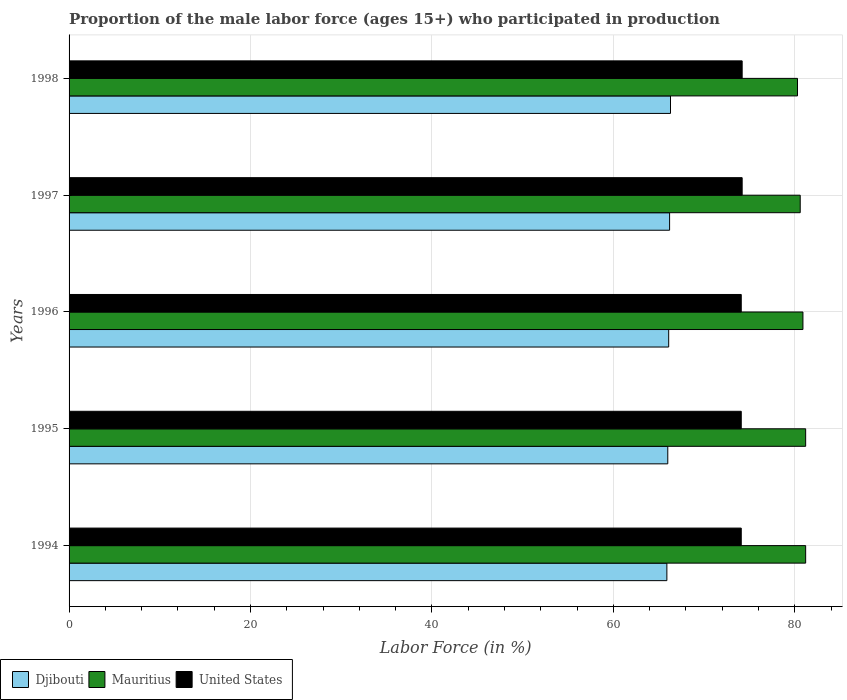How many groups of bars are there?
Ensure brevity in your answer.  5. Are the number of bars per tick equal to the number of legend labels?
Give a very brief answer. Yes. Are the number of bars on each tick of the Y-axis equal?
Your answer should be compact. Yes. How many bars are there on the 3rd tick from the top?
Provide a short and direct response. 3. In how many cases, is the number of bars for a given year not equal to the number of legend labels?
Your answer should be compact. 0. What is the proportion of the male labor force who participated in production in Djibouti in 1996?
Your answer should be compact. 66.1. Across all years, what is the maximum proportion of the male labor force who participated in production in Mauritius?
Ensure brevity in your answer.  81.2. Across all years, what is the minimum proportion of the male labor force who participated in production in United States?
Make the answer very short. 74.1. In which year was the proportion of the male labor force who participated in production in Mauritius minimum?
Provide a succinct answer. 1998. What is the total proportion of the male labor force who participated in production in Djibouti in the graph?
Your response must be concise. 330.5. What is the difference between the proportion of the male labor force who participated in production in United States in 1996 and that in 1998?
Your answer should be compact. -0.1. What is the average proportion of the male labor force who participated in production in Djibouti per year?
Provide a short and direct response. 66.1. In the year 1998, what is the difference between the proportion of the male labor force who participated in production in Mauritius and proportion of the male labor force who participated in production in Djibouti?
Your answer should be compact. 14. In how many years, is the proportion of the male labor force who participated in production in Djibouti greater than 44 %?
Provide a short and direct response. 5. What is the ratio of the proportion of the male labor force who participated in production in United States in 1996 to that in 1997?
Offer a terse response. 1. What is the difference between the highest and the lowest proportion of the male labor force who participated in production in United States?
Make the answer very short. 0.1. In how many years, is the proportion of the male labor force who participated in production in Mauritius greater than the average proportion of the male labor force who participated in production in Mauritius taken over all years?
Offer a terse response. 3. What does the 3rd bar from the top in 1995 represents?
Provide a succinct answer. Djibouti. What does the 2nd bar from the bottom in 1996 represents?
Provide a succinct answer. Mauritius. How many bars are there?
Make the answer very short. 15. How many years are there in the graph?
Make the answer very short. 5. Does the graph contain any zero values?
Your answer should be very brief. No. Does the graph contain grids?
Keep it short and to the point. Yes. Where does the legend appear in the graph?
Your answer should be very brief. Bottom left. How many legend labels are there?
Provide a succinct answer. 3. What is the title of the graph?
Make the answer very short. Proportion of the male labor force (ages 15+) who participated in production. What is the label or title of the X-axis?
Your response must be concise. Labor Force (in %). What is the Labor Force (in %) in Djibouti in 1994?
Keep it short and to the point. 65.9. What is the Labor Force (in %) of Mauritius in 1994?
Your answer should be compact. 81.2. What is the Labor Force (in %) of United States in 1994?
Your response must be concise. 74.1. What is the Labor Force (in %) of Mauritius in 1995?
Offer a terse response. 81.2. What is the Labor Force (in %) of United States in 1995?
Your response must be concise. 74.1. What is the Labor Force (in %) of Djibouti in 1996?
Provide a succinct answer. 66.1. What is the Labor Force (in %) in Mauritius in 1996?
Give a very brief answer. 80.9. What is the Labor Force (in %) in United States in 1996?
Your response must be concise. 74.1. What is the Labor Force (in %) in Djibouti in 1997?
Give a very brief answer. 66.2. What is the Labor Force (in %) of Mauritius in 1997?
Your answer should be very brief. 80.6. What is the Labor Force (in %) of United States in 1997?
Your answer should be very brief. 74.2. What is the Labor Force (in %) in Djibouti in 1998?
Provide a short and direct response. 66.3. What is the Labor Force (in %) of Mauritius in 1998?
Offer a very short reply. 80.3. What is the Labor Force (in %) of United States in 1998?
Your answer should be compact. 74.2. Across all years, what is the maximum Labor Force (in %) in Djibouti?
Keep it short and to the point. 66.3. Across all years, what is the maximum Labor Force (in %) of Mauritius?
Ensure brevity in your answer.  81.2. Across all years, what is the maximum Labor Force (in %) of United States?
Offer a very short reply. 74.2. Across all years, what is the minimum Labor Force (in %) of Djibouti?
Your answer should be very brief. 65.9. Across all years, what is the minimum Labor Force (in %) of Mauritius?
Provide a short and direct response. 80.3. Across all years, what is the minimum Labor Force (in %) of United States?
Your answer should be very brief. 74.1. What is the total Labor Force (in %) in Djibouti in the graph?
Keep it short and to the point. 330.5. What is the total Labor Force (in %) in Mauritius in the graph?
Provide a short and direct response. 404.2. What is the total Labor Force (in %) of United States in the graph?
Offer a terse response. 370.7. What is the difference between the Labor Force (in %) of Mauritius in 1994 and that in 1995?
Provide a short and direct response. 0. What is the difference between the Labor Force (in %) in Djibouti in 1994 and that in 1996?
Ensure brevity in your answer.  -0.2. What is the difference between the Labor Force (in %) in United States in 1994 and that in 1996?
Keep it short and to the point. 0. What is the difference between the Labor Force (in %) of Djibouti in 1994 and that in 1997?
Your response must be concise. -0.3. What is the difference between the Labor Force (in %) in United States in 1994 and that in 1997?
Make the answer very short. -0.1. What is the difference between the Labor Force (in %) in Mauritius in 1994 and that in 1998?
Your answer should be compact. 0.9. What is the difference between the Labor Force (in %) of Djibouti in 1995 and that in 1996?
Ensure brevity in your answer.  -0.1. What is the difference between the Labor Force (in %) of United States in 1995 and that in 1996?
Ensure brevity in your answer.  0. What is the difference between the Labor Force (in %) of Djibouti in 1995 and that in 1997?
Keep it short and to the point. -0.2. What is the difference between the Labor Force (in %) in United States in 1995 and that in 1998?
Your response must be concise. -0.1. What is the difference between the Labor Force (in %) of United States in 1996 and that in 1997?
Give a very brief answer. -0.1. What is the difference between the Labor Force (in %) in Djibouti in 1997 and that in 1998?
Your answer should be compact. -0.1. What is the difference between the Labor Force (in %) in Mauritius in 1997 and that in 1998?
Ensure brevity in your answer.  0.3. What is the difference between the Labor Force (in %) in Djibouti in 1994 and the Labor Force (in %) in Mauritius in 1995?
Keep it short and to the point. -15.3. What is the difference between the Labor Force (in %) of Djibouti in 1994 and the Labor Force (in %) of United States in 1995?
Your answer should be very brief. -8.2. What is the difference between the Labor Force (in %) of Djibouti in 1994 and the Labor Force (in %) of Mauritius in 1996?
Your answer should be compact. -15. What is the difference between the Labor Force (in %) in Djibouti in 1994 and the Labor Force (in %) in United States in 1996?
Ensure brevity in your answer.  -8.2. What is the difference between the Labor Force (in %) in Mauritius in 1994 and the Labor Force (in %) in United States in 1996?
Provide a short and direct response. 7.1. What is the difference between the Labor Force (in %) of Djibouti in 1994 and the Labor Force (in %) of Mauritius in 1997?
Your answer should be very brief. -14.7. What is the difference between the Labor Force (in %) of Mauritius in 1994 and the Labor Force (in %) of United States in 1997?
Keep it short and to the point. 7. What is the difference between the Labor Force (in %) of Djibouti in 1994 and the Labor Force (in %) of Mauritius in 1998?
Offer a terse response. -14.4. What is the difference between the Labor Force (in %) in Djibouti in 1994 and the Labor Force (in %) in United States in 1998?
Offer a very short reply. -8.3. What is the difference between the Labor Force (in %) in Djibouti in 1995 and the Labor Force (in %) in Mauritius in 1996?
Offer a terse response. -14.9. What is the difference between the Labor Force (in %) of Djibouti in 1995 and the Labor Force (in %) of United States in 1996?
Provide a succinct answer. -8.1. What is the difference between the Labor Force (in %) in Djibouti in 1995 and the Labor Force (in %) in Mauritius in 1997?
Your answer should be very brief. -14.6. What is the difference between the Labor Force (in %) of Djibouti in 1995 and the Labor Force (in %) of Mauritius in 1998?
Ensure brevity in your answer.  -14.3. What is the difference between the Labor Force (in %) in Djibouti in 1995 and the Labor Force (in %) in United States in 1998?
Keep it short and to the point. -8.2. What is the difference between the Labor Force (in %) of Djibouti in 1996 and the Labor Force (in %) of United States in 1997?
Your response must be concise. -8.1. What is the difference between the Labor Force (in %) of Mauritius in 1996 and the Labor Force (in %) of United States in 1997?
Offer a terse response. 6.7. What is the difference between the Labor Force (in %) of Djibouti in 1996 and the Labor Force (in %) of United States in 1998?
Make the answer very short. -8.1. What is the difference between the Labor Force (in %) of Mauritius in 1996 and the Labor Force (in %) of United States in 1998?
Give a very brief answer. 6.7. What is the difference between the Labor Force (in %) in Djibouti in 1997 and the Labor Force (in %) in Mauritius in 1998?
Your answer should be compact. -14.1. What is the average Labor Force (in %) of Djibouti per year?
Offer a terse response. 66.1. What is the average Labor Force (in %) of Mauritius per year?
Your answer should be very brief. 80.84. What is the average Labor Force (in %) in United States per year?
Provide a short and direct response. 74.14. In the year 1994, what is the difference between the Labor Force (in %) in Djibouti and Labor Force (in %) in Mauritius?
Offer a terse response. -15.3. In the year 1994, what is the difference between the Labor Force (in %) of Djibouti and Labor Force (in %) of United States?
Offer a very short reply. -8.2. In the year 1994, what is the difference between the Labor Force (in %) in Mauritius and Labor Force (in %) in United States?
Offer a terse response. 7.1. In the year 1995, what is the difference between the Labor Force (in %) in Djibouti and Labor Force (in %) in Mauritius?
Make the answer very short. -15.2. In the year 1995, what is the difference between the Labor Force (in %) in Djibouti and Labor Force (in %) in United States?
Provide a short and direct response. -8.1. In the year 1995, what is the difference between the Labor Force (in %) of Mauritius and Labor Force (in %) of United States?
Provide a succinct answer. 7.1. In the year 1996, what is the difference between the Labor Force (in %) of Djibouti and Labor Force (in %) of Mauritius?
Ensure brevity in your answer.  -14.8. In the year 1996, what is the difference between the Labor Force (in %) in Djibouti and Labor Force (in %) in United States?
Provide a succinct answer. -8. In the year 1997, what is the difference between the Labor Force (in %) in Djibouti and Labor Force (in %) in Mauritius?
Ensure brevity in your answer.  -14.4. In the year 1997, what is the difference between the Labor Force (in %) in Djibouti and Labor Force (in %) in United States?
Offer a very short reply. -8. In the year 1997, what is the difference between the Labor Force (in %) of Mauritius and Labor Force (in %) of United States?
Your response must be concise. 6.4. In the year 1998, what is the difference between the Labor Force (in %) in Djibouti and Labor Force (in %) in Mauritius?
Provide a succinct answer. -14. In the year 1998, what is the difference between the Labor Force (in %) in Djibouti and Labor Force (in %) in United States?
Provide a succinct answer. -7.9. What is the ratio of the Labor Force (in %) of Djibouti in 1994 to that in 1995?
Your response must be concise. 1. What is the ratio of the Labor Force (in %) in Mauritius in 1994 to that in 1995?
Offer a very short reply. 1. What is the ratio of the Labor Force (in %) in Djibouti in 1994 to that in 1996?
Provide a short and direct response. 1. What is the ratio of the Labor Force (in %) of Mauritius in 1994 to that in 1996?
Your answer should be compact. 1. What is the ratio of the Labor Force (in %) of United States in 1994 to that in 1996?
Provide a short and direct response. 1. What is the ratio of the Labor Force (in %) in Djibouti in 1994 to that in 1997?
Keep it short and to the point. 1. What is the ratio of the Labor Force (in %) of Mauritius in 1994 to that in 1997?
Ensure brevity in your answer.  1.01. What is the ratio of the Labor Force (in %) in Mauritius in 1994 to that in 1998?
Your answer should be compact. 1.01. What is the ratio of the Labor Force (in %) in United States in 1994 to that in 1998?
Your answer should be compact. 1. What is the ratio of the Labor Force (in %) of United States in 1995 to that in 1996?
Your answer should be very brief. 1. What is the ratio of the Labor Force (in %) in Mauritius in 1995 to that in 1997?
Provide a succinct answer. 1.01. What is the ratio of the Labor Force (in %) in United States in 1995 to that in 1997?
Provide a short and direct response. 1. What is the ratio of the Labor Force (in %) in Djibouti in 1995 to that in 1998?
Provide a short and direct response. 1. What is the ratio of the Labor Force (in %) in Mauritius in 1995 to that in 1998?
Your response must be concise. 1.01. What is the ratio of the Labor Force (in %) of Mauritius in 1996 to that in 1997?
Provide a short and direct response. 1. What is the ratio of the Labor Force (in %) of Djibouti in 1996 to that in 1998?
Provide a short and direct response. 1. What is the ratio of the Labor Force (in %) in Mauritius in 1996 to that in 1998?
Your answer should be compact. 1.01. What is the ratio of the Labor Force (in %) in Djibouti in 1997 to that in 1998?
Your response must be concise. 1. What is the difference between the highest and the second highest Labor Force (in %) in Mauritius?
Your answer should be very brief. 0. What is the difference between the highest and the second highest Labor Force (in %) of United States?
Your answer should be very brief. 0. What is the difference between the highest and the lowest Labor Force (in %) in Mauritius?
Your answer should be compact. 0.9. What is the difference between the highest and the lowest Labor Force (in %) of United States?
Ensure brevity in your answer.  0.1. 